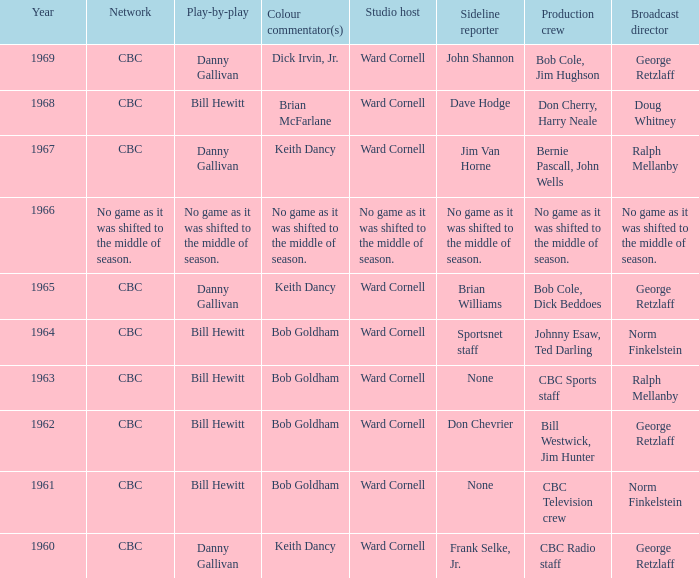Who did the play-by-play on the CBC network before 1961? Danny Gallivan. Write the full table. {'header': ['Year', 'Network', 'Play-by-play', 'Colour commentator(s)', 'Studio host', 'Sideline reporter', 'Production crew', 'Broadcast director'], 'rows': [['1969', 'CBC', 'Danny Gallivan', 'Dick Irvin, Jr.', 'Ward Cornell', 'John Shannon', 'Bob Cole, Jim Hughson', 'George Retzlaff'], ['1968', 'CBC', 'Bill Hewitt', 'Brian McFarlane', 'Ward Cornell', 'Dave Hodge', 'Don Cherry, Harry Neale', 'Doug Whitney'], ['1967', 'CBC', 'Danny Gallivan', 'Keith Dancy', 'Ward Cornell', 'Jim Van Horne', 'Bernie Pascall, John Wells', 'Ralph Mellanby'], ['1966', 'No game as it was shifted to the middle of season.', 'No game as it was shifted to the middle of season.', 'No game as it was shifted to the middle of season.', 'No game as it was shifted to the middle of season.', 'No game as it was shifted to the middle of season.', 'No game as it was shifted to the middle of season.', 'No game as it was shifted to the middle of season.'], ['1965', 'CBC', 'Danny Gallivan', 'Keith Dancy', 'Ward Cornell', 'Brian Williams', 'Bob Cole, Dick Beddoes', 'George Retzlaff'], ['1964', 'CBC', 'Bill Hewitt', 'Bob Goldham', 'Ward Cornell', 'Sportsnet staff', 'Johnny Esaw, Ted Darling', 'Norm Finkelstein'], ['1963', 'CBC', 'Bill Hewitt', 'Bob Goldham', 'Ward Cornell', 'None', 'CBC Sports staff', 'Ralph Mellanby'], ['1962', 'CBC', 'Bill Hewitt', 'Bob Goldham', 'Ward Cornell', 'Don Chevrier', 'Bill Westwick, Jim Hunter', 'George Retzlaff'], ['1961', 'CBC', 'Bill Hewitt', 'Bob Goldham', 'Ward Cornell', 'None', 'CBC Television crew', 'Norm Finkelstein'], ['1960', 'CBC', 'Danny Gallivan', 'Keith Dancy', 'Ward Cornell', 'Frank Selke, Jr.', 'CBC Radio staff', 'George Retzlaff']]} 